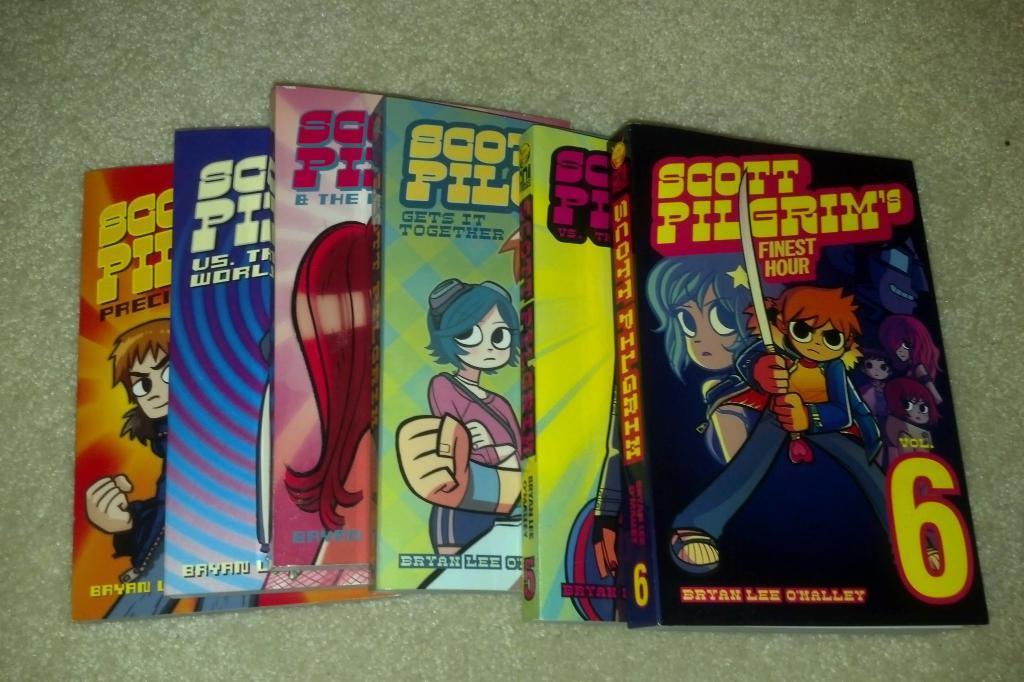Could you give a brief overview of what you see in this image? In this image there are boxes of a compact disk, there are persons on the box, there is text on the boxes, there is number on the boxes, at the background of the image there is an object which is green in color. 